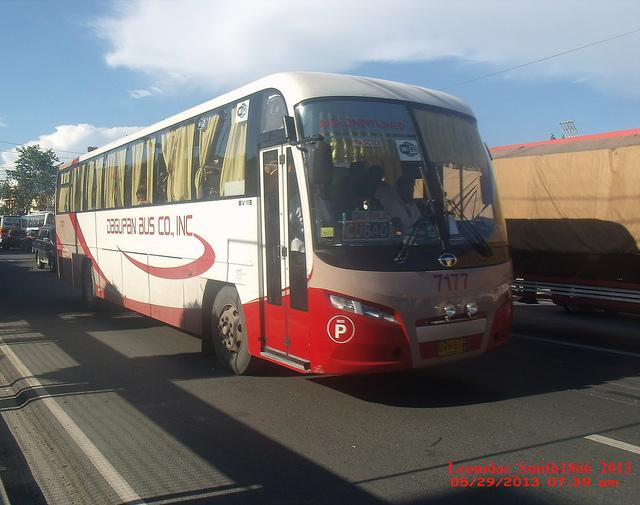Which street lane or lanes is the bus traveling in? Please explain your reasoning. both lanes. Both lanes are open. 